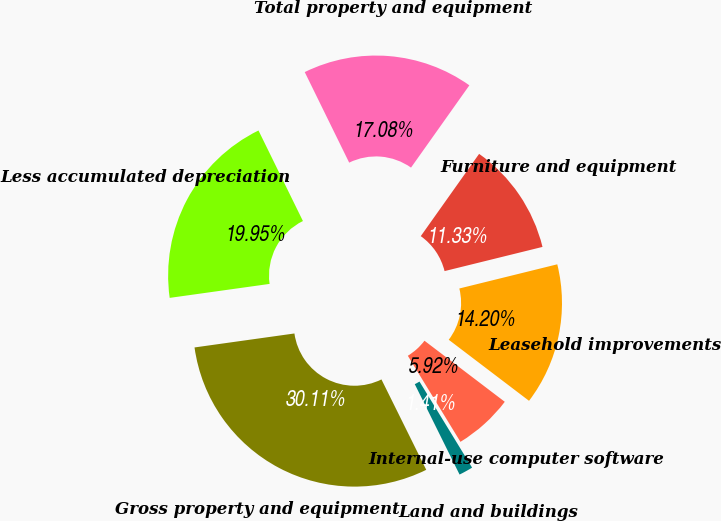Convert chart. <chart><loc_0><loc_0><loc_500><loc_500><pie_chart><fcel>Furniture and equipment<fcel>Leasehold improvements<fcel>Internal-use computer software<fcel>Land and buildings<fcel>Gross property and equipment<fcel>Less accumulated depreciation<fcel>Total property and equipment<nl><fcel>11.33%<fcel>14.2%<fcel>5.92%<fcel>1.41%<fcel>30.11%<fcel>19.95%<fcel>17.08%<nl></chart> 